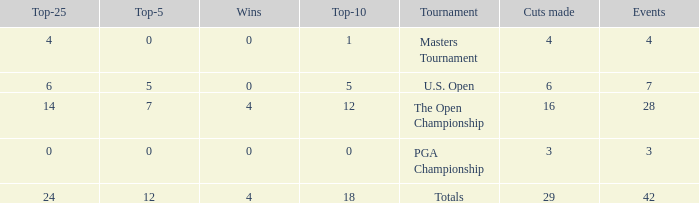What are the highest wins with cuts smaller than 6, events of 4 and a top-5 smaller than 0? None. 